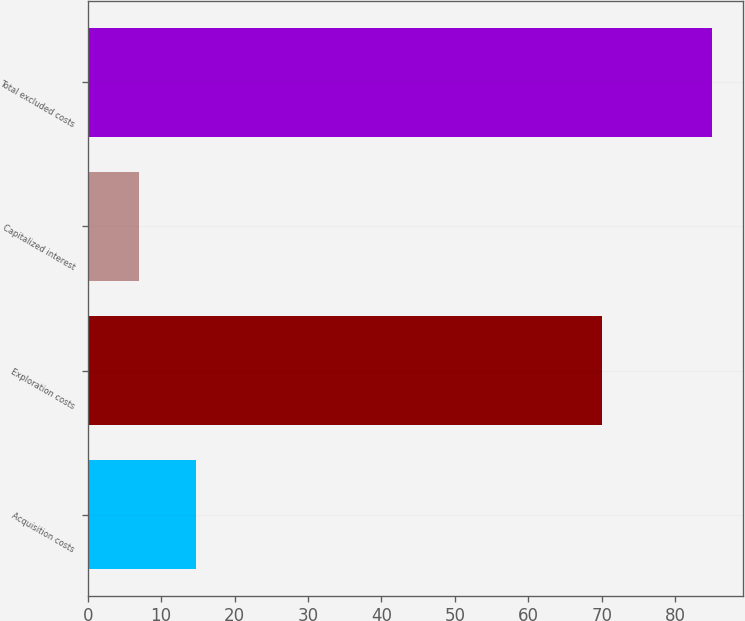<chart> <loc_0><loc_0><loc_500><loc_500><bar_chart><fcel>Acquisition costs<fcel>Exploration costs<fcel>Capitalized interest<fcel>Total excluded costs<nl><fcel>14.8<fcel>70<fcel>7<fcel>85<nl></chart> 